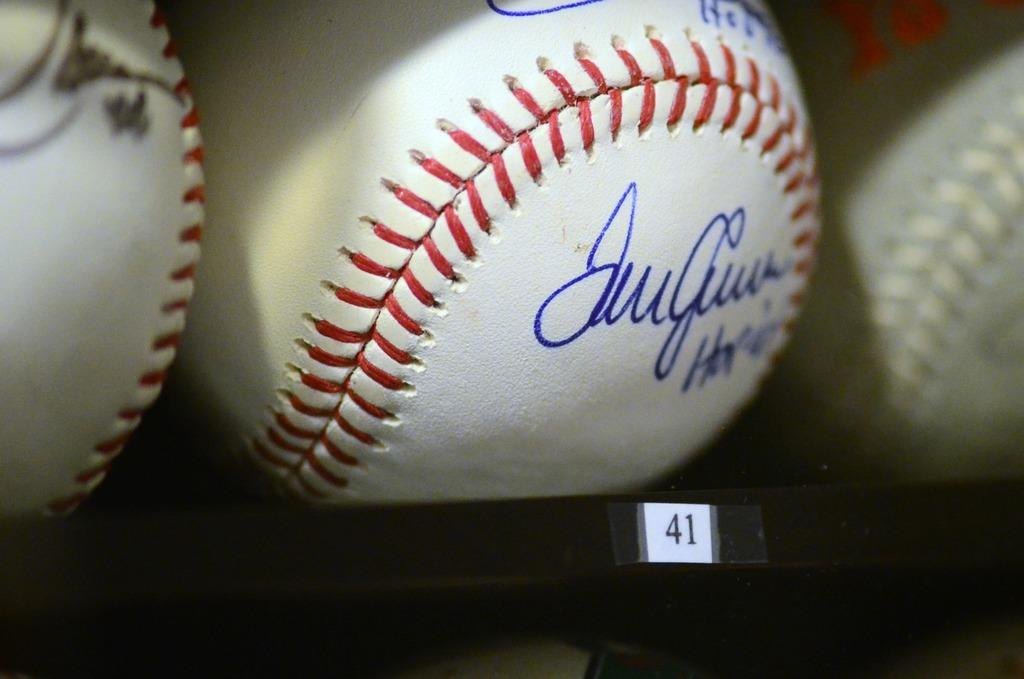<image>
Provide a brief description of the given image. An autographed baseball with the number 41 under it 